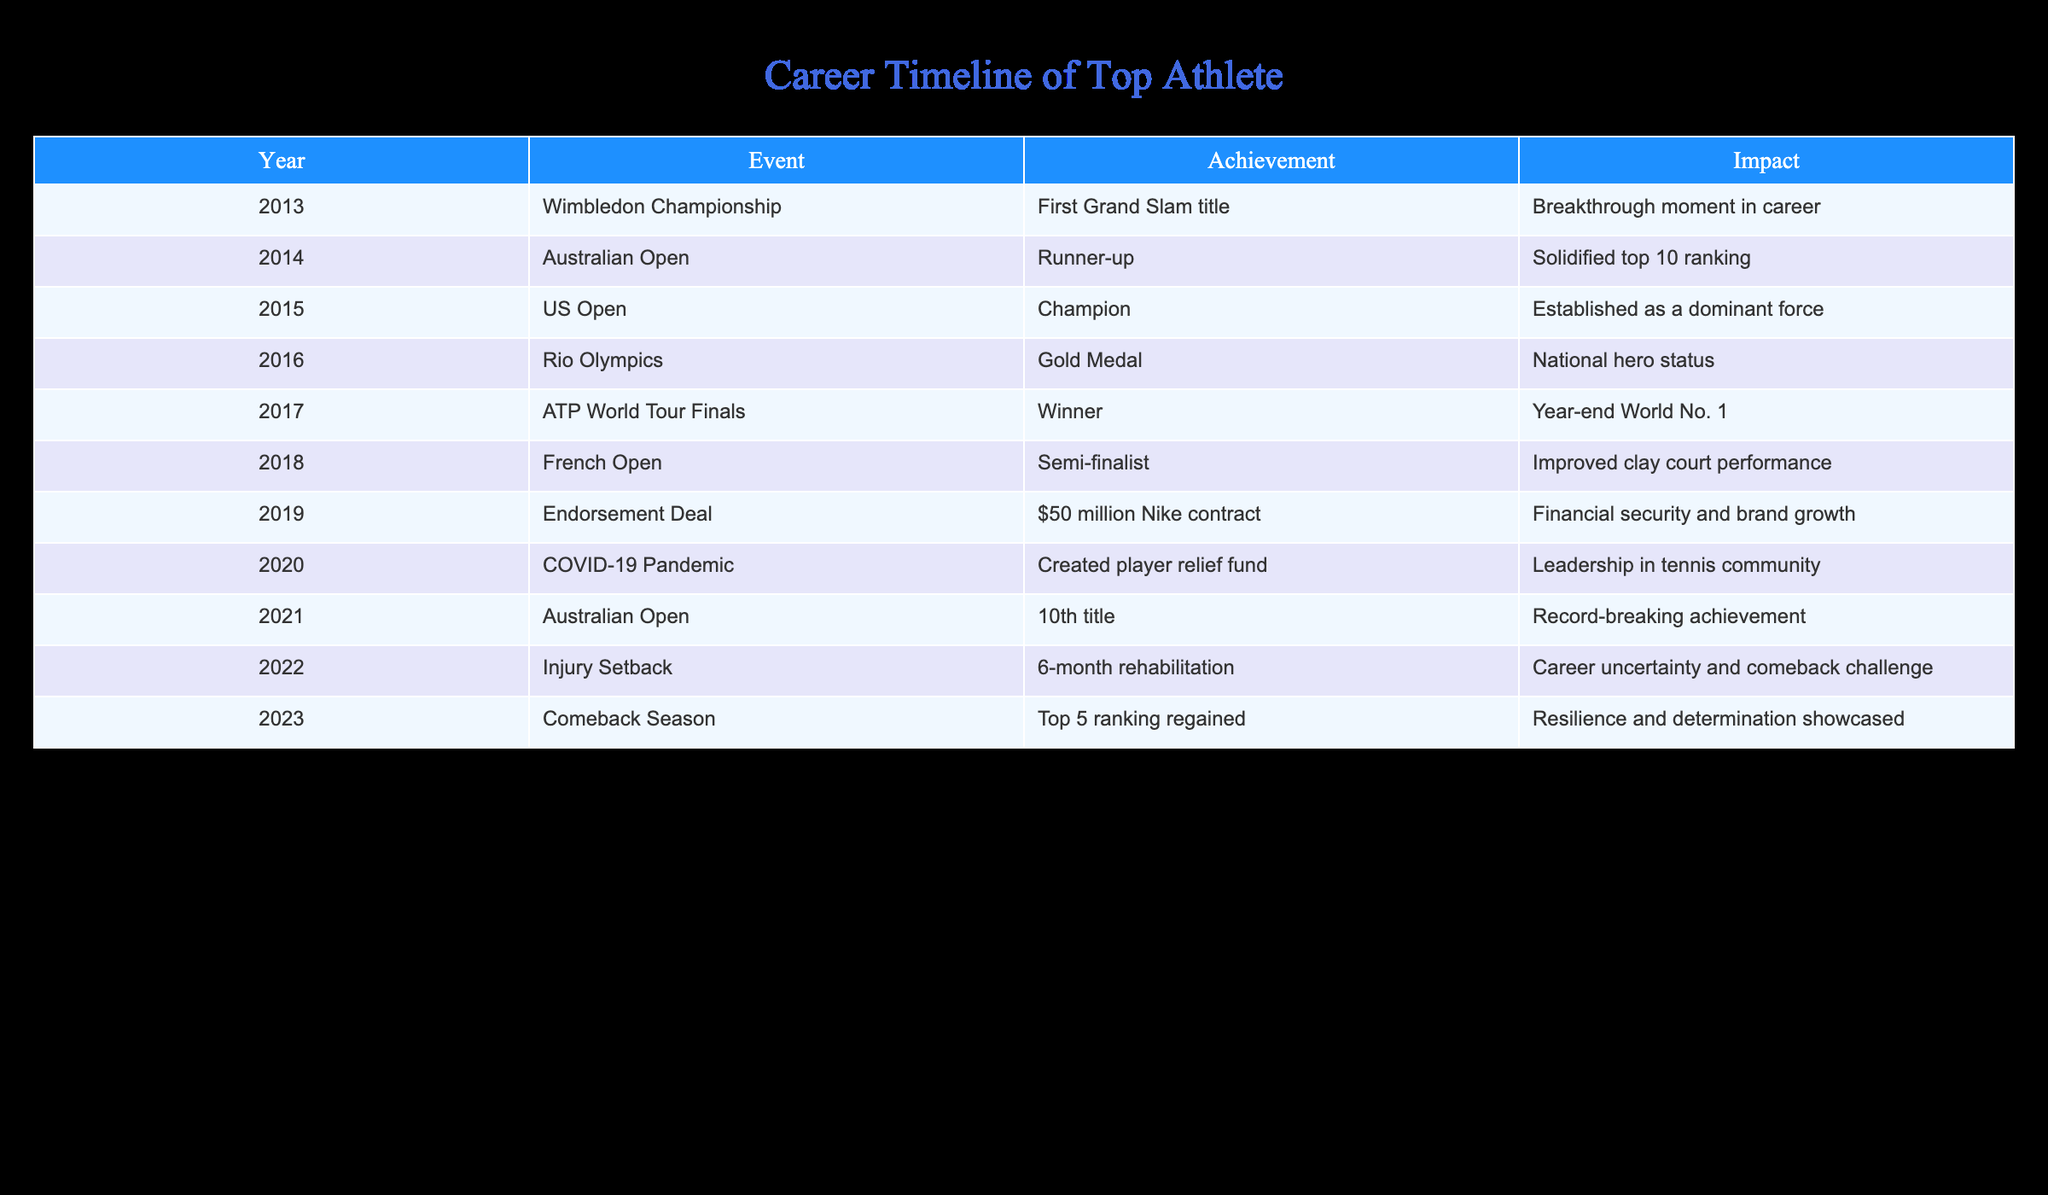What was the athlete's first Grand Slam title? The table shows that the athlete won their first Grand Slam title at the Wimbledon Championship in 2013.
Answer: Wimbledon Championship In which year did the athlete achieve a top 5 ranking again? According to the table, the athlete regained a top 5 ranking in the year 2023.
Answer: 2023 How many Grand Slam titles did the athlete win by 2021? The table indicates that the athlete won their 10th title at the Australian Open in 2021, which means they had 10 Grand Slam titles by that year.
Answer: 10 Was the athlete a runner-up at any Grand Slam event? The table confirms that in 2014, the athlete was the runner-up at the Australian Open.
Answer: Yes What impact did the endorsement deal in 2019 have on the athlete’s career? The table notes that the endorsement deal in 2019 provided the athlete with financial security and contributed to their brand growth.
Answer: Financial security and brand growth What was the achievement during the 2016 Rio Olympics? The table states that the athlete won a gold medal at the Rio Olympics in 2016, which elevated their status to that of a national hero.
Answer: Gold Medal How does the injury setback in 2022 compare to the previous year's achievements? In 2021, the athlete achieved their 10th title, but in 2022, they faced a 6-month rehabilitation from an injury, which created uncertainty around their career. This shows a significant setback following a peak achievement.
Answer: Significant setback following a peak achievement What year marked the athlete's year-end ranking as World No. 1? The athlete was ranked World No. 1 at the end of the year in 2017 as indicated in the table.
Answer: 2017 How did the COVID-19 pandemic impact the athlete's role in the community? The table indicates that during the COVID-19 pandemic in 2020, the athlete created a player relief fund, showcasing their leadership within the tennis community.
Answer: Leadership in tennis community 